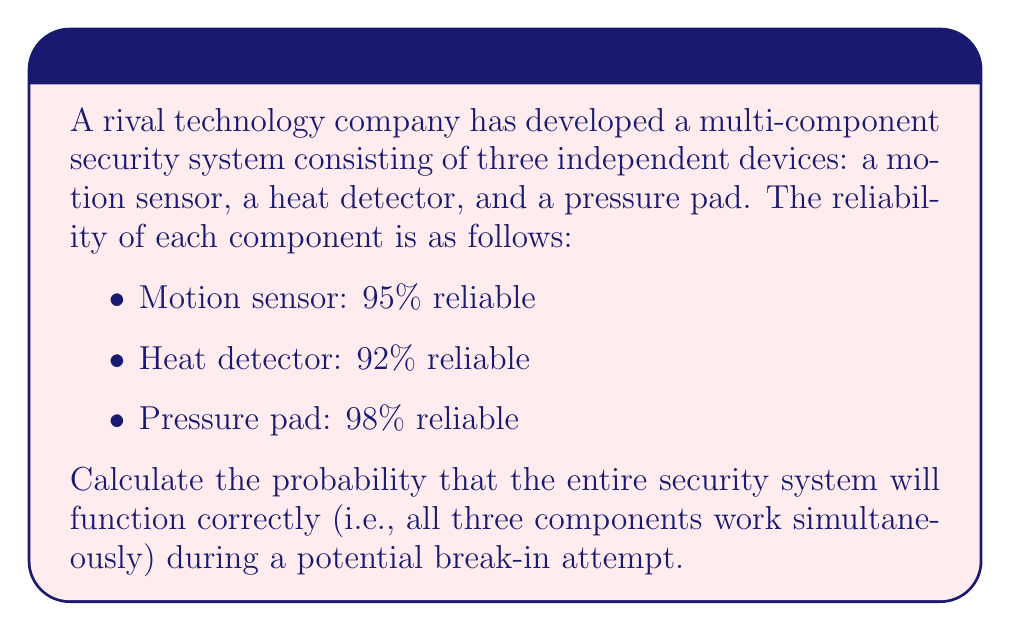Provide a solution to this math problem. To solve this problem, we need to use the concept of joint probability for independent events. Since all three components must work simultaneously for the system to function correctly, we need to calculate the probability of all three events occurring together.

Let's define the events:
- A: Motion sensor works (P(A) = 0.95)
- B: Heat detector works (P(B) = 0.92)
- C: Pressure pad works (P(C) = 0.98)

For independent events, the joint probability is the product of the individual probabilities:

$$ P(A \cap B \cap C) = P(A) \times P(B) \times P(C) $$

Substituting the given probabilities:

$$ P(A \cap B \cap C) = 0.95 \times 0.92 \times 0.98 $$

Calculating:

$$ P(A \cap B \cap C) = 0.8556 $$

Therefore, the probability that the entire security system will function correctly is approximately 0.8556 or 85.56%.
Answer: 0.8556 